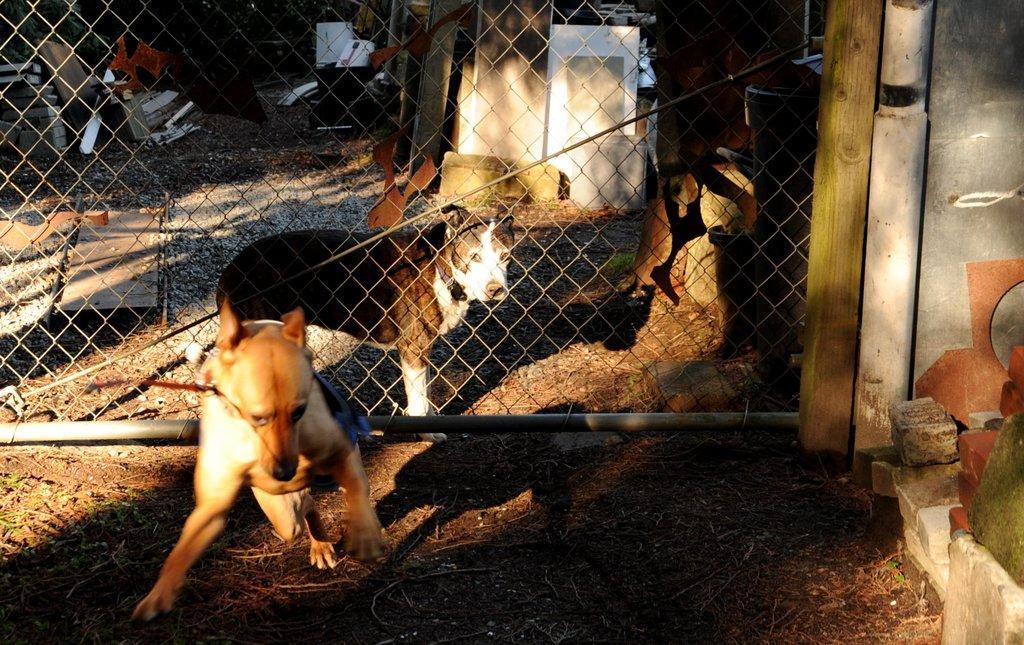How would you summarize this image in a sentence or two? In this image in the front there is an animal and there are stones and objects. In the center there is a net and behind the net there are objects and there are stones. 